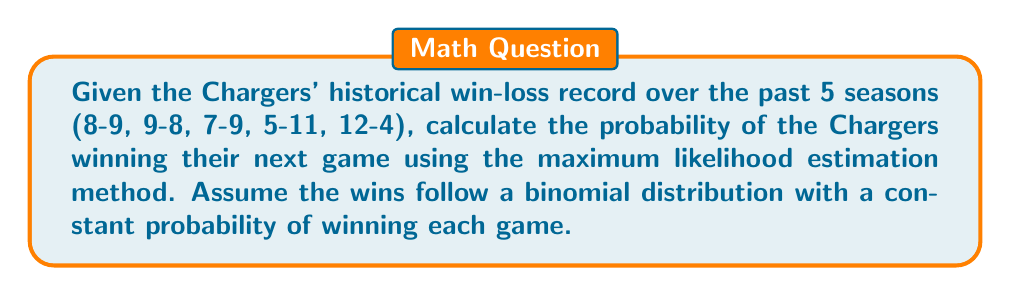Could you help me with this problem? To solve this problem, we'll follow these steps:

1) First, we need to calculate the total number of wins and total number of games:
   Total wins = 8 + 9 + 7 + 5 + 12 = 41
   Total games = 17 + 17 + 16 + 16 + 16 = 82

2) The maximum likelihood estimator for the probability of success in a binomial distribution is given by:

   $$ p = \frac{\text{number of successes}}{\text{number of trials}} $$

3) Substituting our values:

   $$ p = \frac{41}{82} = 0.5 $$

4) This means that based on the historical data, the estimated probability of the Chargers winning any given game is 0.5 or 50%.

5) To express this as a probability, we keep it as 0.5.

Note: This method assumes that each game is independent and that the probability of winning remains constant over time, which may not be entirely accurate in real-world scenarios due to factors like changes in team composition, coaching, and opponents.
Answer: 0.5 